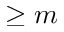<formula> <loc_0><loc_0><loc_500><loc_500>\geq m</formula> 